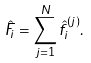<formula> <loc_0><loc_0><loc_500><loc_500>\hat { F } _ { i } = \sum _ { j = 1 } ^ { N } \hat { f } _ { i } ^ { ( j ) } .</formula> 